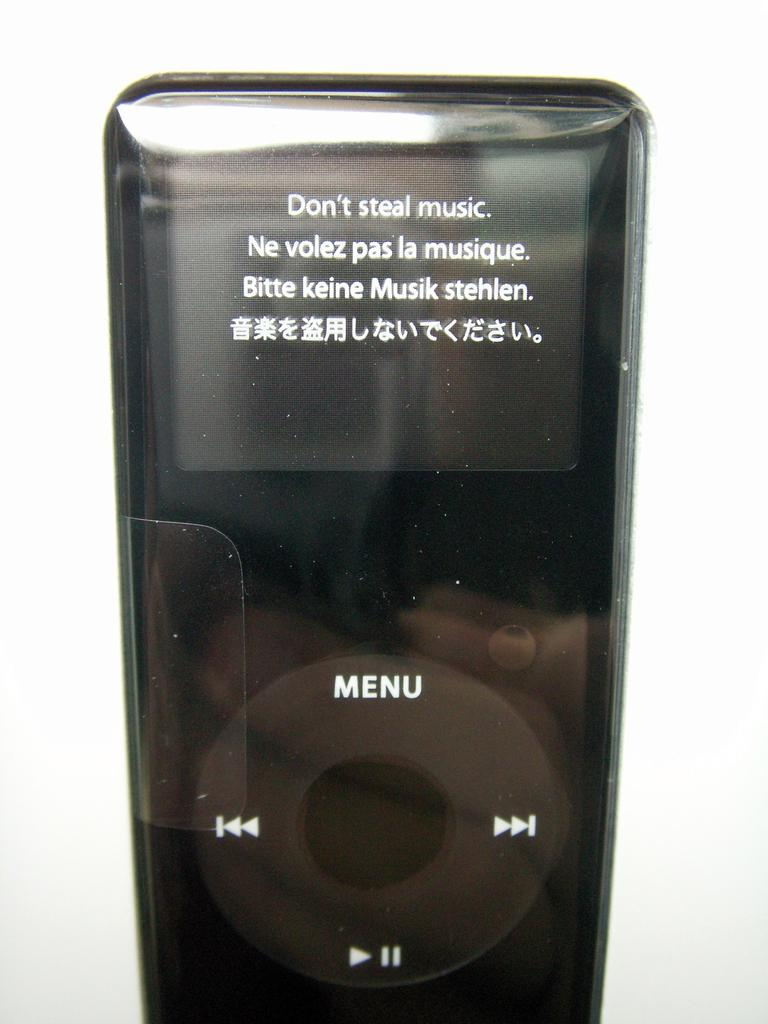What is the main object in the center of the image? There is a remote in the center of the image. What can be seen on the remote? There is text on the remote. What is visible in the background of the image? There is a wall in the background of the image. What type of fuel is being used by the crate in the image? There is no crate present in the image, and therefore no fuel usage can be observed. What is the topic of the argument taking place in the image? There is no argument present in the image, so it is not possible to determine the topic. 